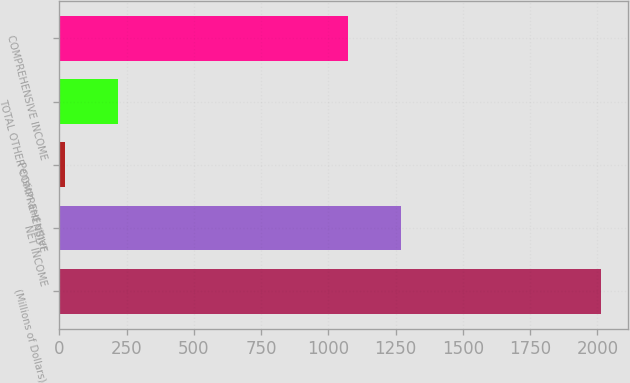Convert chart. <chart><loc_0><loc_0><loc_500><loc_500><bar_chart><fcel>(Millions of Dollars)<fcel>NET INCOME<fcel>Pension and other<fcel>TOTAL OTHER COMPREHENSIVE<fcel>COMPREHENSIVE INCOME<nl><fcel>2014<fcel>1271.4<fcel>20<fcel>219.4<fcel>1072<nl></chart> 